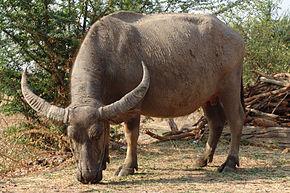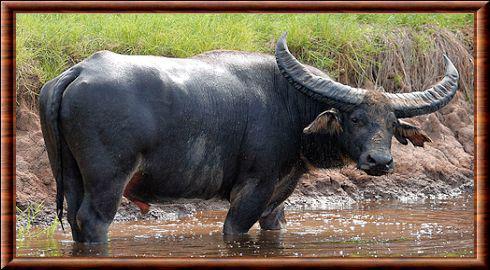The first image is the image on the left, the second image is the image on the right. Evaluate the accuracy of this statement regarding the images: "Exactly one image shows a water buffalo standing in water, and there is only one animal in the image.". Is it true? Answer yes or no. Yes. The first image is the image on the left, the second image is the image on the right. For the images displayed, is the sentence "At least one cow is standing chest deep in water." factually correct? Answer yes or no. No. 